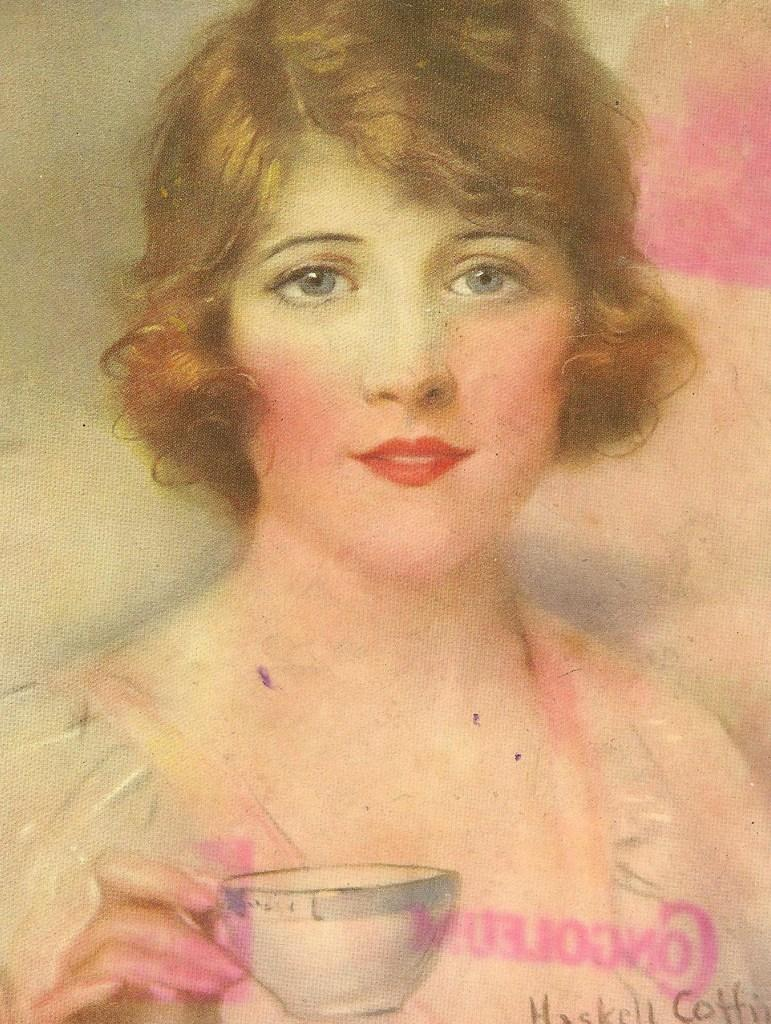What type of image is being described? The image is a vintage photograph. Who or what is the main subject of the photograph? The photograph features a girl. What is the girl holding in the photograph? The girl is holding a cup. How many houses can be seen in the background of the photograph? There are no houses visible in the photograph; it is a close-up of the girl holding a cup. 